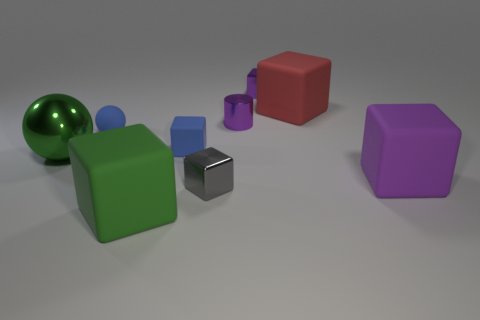Is there a big block of the same color as the tiny metal cylinder?
Your answer should be very brief. Yes. Do the metal thing right of the small shiny cylinder and the shiny cylinder behind the small blue sphere have the same color?
Provide a short and direct response. Yes. The metal cylinder is what color?
Provide a succinct answer. Purple. Is there a small brown rubber cylinder?
Your answer should be compact. No. There is a green ball; are there any large blocks on the left side of it?
Offer a terse response. No. What is the material of the small blue thing that is the same shape as the large metal thing?
Provide a succinct answer. Rubber. What number of other objects are the same shape as the green matte object?
Offer a very short reply. 5. There is a purple cube behind the big green object that is behind the large purple rubber cube; how many large red matte blocks are behind it?
Provide a short and direct response. 0. How many other small objects have the same shape as the green rubber thing?
Offer a terse response. 3. Do the big matte cube that is to the left of the small purple metal cylinder and the large metal thing have the same color?
Provide a succinct answer. Yes. 